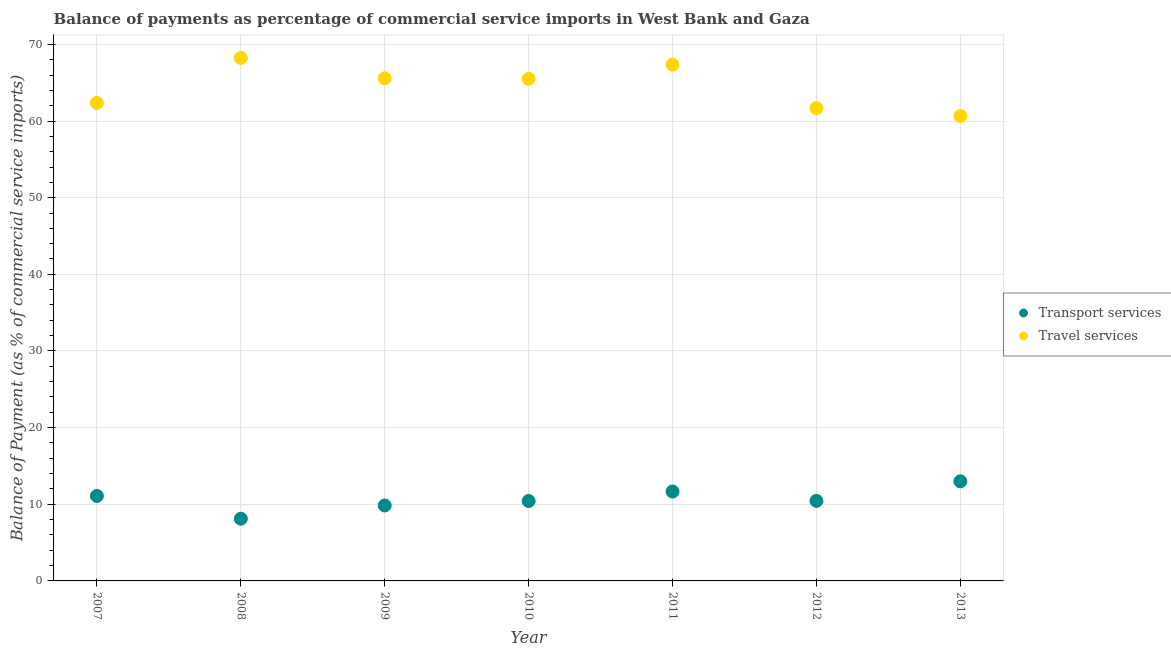How many different coloured dotlines are there?
Make the answer very short. 2. Is the number of dotlines equal to the number of legend labels?
Give a very brief answer. Yes. What is the balance of payments of transport services in 2010?
Your answer should be compact. 10.43. Across all years, what is the maximum balance of payments of transport services?
Offer a very short reply. 12.99. Across all years, what is the minimum balance of payments of travel services?
Make the answer very short. 60.66. In which year was the balance of payments of travel services maximum?
Offer a terse response. 2008. In which year was the balance of payments of transport services minimum?
Your answer should be compact. 2008. What is the total balance of payments of transport services in the graph?
Your answer should be very brief. 74.57. What is the difference between the balance of payments of transport services in 2008 and that in 2013?
Keep it short and to the point. -4.88. What is the difference between the balance of payments of travel services in 2010 and the balance of payments of transport services in 2012?
Offer a very short reply. 55.06. What is the average balance of payments of transport services per year?
Your response must be concise. 10.65. In the year 2008, what is the difference between the balance of payments of travel services and balance of payments of transport services?
Provide a short and direct response. 60.12. What is the ratio of the balance of payments of transport services in 2007 to that in 2010?
Ensure brevity in your answer.  1.06. Is the balance of payments of transport services in 2007 less than that in 2012?
Provide a short and direct response. No. Is the difference between the balance of payments of transport services in 2007 and 2010 greater than the difference between the balance of payments of travel services in 2007 and 2010?
Keep it short and to the point. Yes. What is the difference between the highest and the second highest balance of payments of transport services?
Provide a short and direct response. 1.33. What is the difference between the highest and the lowest balance of payments of transport services?
Make the answer very short. 4.88. Is the sum of the balance of payments of transport services in 2008 and 2013 greater than the maximum balance of payments of travel services across all years?
Give a very brief answer. No. Does the balance of payments of travel services monotonically increase over the years?
Provide a succinct answer. No. Is the balance of payments of travel services strictly greater than the balance of payments of transport services over the years?
Your answer should be very brief. Yes. How many dotlines are there?
Your answer should be very brief. 2. Does the graph contain grids?
Offer a terse response. Yes. Where does the legend appear in the graph?
Your answer should be compact. Center right. How many legend labels are there?
Offer a very short reply. 2. What is the title of the graph?
Your response must be concise. Balance of payments as percentage of commercial service imports in West Bank and Gaza. What is the label or title of the X-axis?
Offer a very short reply. Year. What is the label or title of the Y-axis?
Keep it short and to the point. Balance of Payment (as % of commercial service imports). What is the Balance of Payment (as % of commercial service imports) in Transport services in 2007?
Make the answer very short. 11.09. What is the Balance of Payment (as % of commercial service imports) of Travel services in 2007?
Your response must be concise. 62.36. What is the Balance of Payment (as % of commercial service imports) in Transport services in 2008?
Make the answer very short. 8.12. What is the Balance of Payment (as % of commercial service imports) of Travel services in 2008?
Ensure brevity in your answer.  68.23. What is the Balance of Payment (as % of commercial service imports) of Transport services in 2009?
Keep it short and to the point. 9.84. What is the Balance of Payment (as % of commercial service imports) of Travel services in 2009?
Keep it short and to the point. 65.57. What is the Balance of Payment (as % of commercial service imports) in Transport services in 2010?
Offer a terse response. 10.43. What is the Balance of Payment (as % of commercial service imports) in Travel services in 2010?
Your answer should be very brief. 65.5. What is the Balance of Payment (as % of commercial service imports) in Transport services in 2011?
Offer a very short reply. 11.66. What is the Balance of Payment (as % of commercial service imports) in Travel services in 2011?
Offer a very short reply. 67.34. What is the Balance of Payment (as % of commercial service imports) of Transport services in 2012?
Ensure brevity in your answer.  10.44. What is the Balance of Payment (as % of commercial service imports) of Travel services in 2012?
Offer a very short reply. 61.69. What is the Balance of Payment (as % of commercial service imports) in Transport services in 2013?
Offer a very short reply. 12.99. What is the Balance of Payment (as % of commercial service imports) in Travel services in 2013?
Offer a terse response. 60.66. Across all years, what is the maximum Balance of Payment (as % of commercial service imports) of Transport services?
Ensure brevity in your answer.  12.99. Across all years, what is the maximum Balance of Payment (as % of commercial service imports) in Travel services?
Provide a short and direct response. 68.23. Across all years, what is the minimum Balance of Payment (as % of commercial service imports) of Transport services?
Offer a terse response. 8.12. Across all years, what is the minimum Balance of Payment (as % of commercial service imports) in Travel services?
Your response must be concise. 60.66. What is the total Balance of Payment (as % of commercial service imports) of Transport services in the graph?
Provide a short and direct response. 74.57. What is the total Balance of Payment (as % of commercial service imports) of Travel services in the graph?
Provide a succinct answer. 451.36. What is the difference between the Balance of Payment (as % of commercial service imports) in Transport services in 2007 and that in 2008?
Offer a terse response. 2.97. What is the difference between the Balance of Payment (as % of commercial service imports) of Travel services in 2007 and that in 2008?
Ensure brevity in your answer.  -5.88. What is the difference between the Balance of Payment (as % of commercial service imports) of Transport services in 2007 and that in 2009?
Offer a very short reply. 1.24. What is the difference between the Balance of Payment (as % of commercial service imports) of Travel services in 2007 and that in 2009?
Your answer should be very brief. -3.22. What is the difference between the Balance of Payment (as % of commercial service imports) of Transport services in 2007 and that in 2010?
Keep it short and to the point. 0.66. What is the difference between the Balance of Payment (as % of commercial service imports) in Travel services in 2007 and that in 2010?
Your answer should be very brief. -3.15. What is the difference between the Balance of Payment (as % of commercial service imports) in Transport services in 2007 and that in 2011?
Make the answer very short. -0.58. What is the difference between the Balance of Payment (as % of commercial service imports) of Travel services in 2007 and that in 2011?
Offer a very short reply. -4.99. What is the difference between the Balance of Payment (as % of commercial service imports) of Transport services in 2007 and that in 2012?
Offer a terse response. 0.64. What is the difference between the Balance of Payment (as % of commercial service imports) of Travel services in 2007 and that in 2012?
Provide a succinct answer. 0.67. What is the difference between the Balance of Payment (as % of commercial service imports) of Transport services in 2007 and that in 2013?
Provide a succinct answer. -1.91. What is the difference between the Balance of Payment (as % of commercial service imports) in Travel services in 2007 and that in 2013?
Your response must be concise. 1.7. What is the difference between the Balance of Payment (as % of commercial service imports) in Transport services in 2008 and that in 2009?
Your answer should be very brief. -1.72. What is the difference between the Balance of Payment (as % of commercial service imports) in Travel services in 2008 and that in 2009?
Offer a very short reply. 2.66. What is the difference between the Balance of Payment (as % of commercial service imports) of Transport services in 2008 and that in 2010?
Make the answer very short. -2.31. What is the difference between the Balance of Payment (as % of commercial service imports) of Travel services in 2008 and that in 2010?
Give a very brief answer. 2.73. What is the difference between the Balance of Payment (as % of commercial service imports) in Transport services in 2008 and that in 2011?
Offer a terse response. -3.55. What is the difference between the Balance of Payment (as % of commercial service imports) of Travel services in 2008 and that in 2011?
Your answer should be very brief. 0.89. What is the difference between the Balance of Payment (as % of commercial service imports) of Transport services in 2008 and that in 2012?
Your answer should be very brief. -2.32. What is the difference between the Balance of Payment (as % of commercial service imports) of Travel services in 2008 and that in 2012?
Your answer should be very brief. 6.54. What is the difference between the Balance of Payment (as % of commercial service imports) of Transport services in 2008 and that in 2013?
Your answer should be very brief. -4.88. What is the difference between the Balance of Payment (as % of commercial service imports) of Travel services in 2008 and that in 2013?
Offer a terse response. 7.57. What is the difference between the Balance of Payment (as % of commercial service imports) of Transport services in 2009 and that in 2010?
Offer a very short reply. -0.58. What is the difference between the Balance of Payment (as % of commercial service imports) of Travel services in 2009 and that in 2010?
Keep it short and to the point. 0.07. What is the difference between the Balance of Payment (as % of commercial service imports) in Transport services in 2009 and that in 2011?
Provide a succinct answer. -1.82. What is the difference between the Balance of Payment (as % of commercial service imports) in Travel services in 2009 and that in 2011?
Offer a very short reply. -1.77. What is the difference between the Balance of Payment (as % of commercial service imports) in Transport services in 2009 and that in 2012?
Offer a terse response. -0.6. What is the difference between the Balance of Payment (as % of commercial service imports) of Travel services in 2009 and that in 2012?
Give a very brief answer. 3.89. What is the difference between the Balance of Payment (as % of commercial service imports) of Transport services in 2009 and that in 2013?
Provide a short and direct response. -3.15. What is the difference between the Balance of Payment (as % of commercial service imports) in Travel services in 2009 and that in 2013?
Make the answer very short. 4.91. What is the difference between the Balance of Payment (as % of commercial service imports) of Transport services in 2010 and that in 2011?
Offer a terse response. -1.24. What is the difference between the Balance of Payment (as % of commercial service imports) of Travel services in 2010 and that in 2011?
Provide a succinct answer. -1.84. What is the difference between the Balance of Payment (as % of commercial service imports) of Transport services in 2010 and that in 2012?
Provide a succinct answer. -0.02. What is the difference between the Balance of Payment (as % of commercial service imports) of Travel services in 2010 and that in 2012?
Give a very brief answer. 3.81. What is the difference between the Balance of Payment (as % of commercial service imports) of Transport services in 2010 and that in 2013?
Your answer should be very brief. -2.57. What is the difference between the Balance of Payment (as % of commercial service imports) in Travel services in 2010 and that in 2013?
Offer a terse response. 4.84. What is the difference between the Balance of Payment (as % of commercial service imports) of Transport services in 2011 and that in 2012?
Ensure brevity in your answer.  1.22. What is the difference between the Balance of Payment (as % of commercial service imports) of Travel services in 2011 and that in 2012?
Provide a succinct answer. 5.65. What is the difference between the Balance of Payment (as % of commercial service imports) in Transport services in 2011 and that in 2013?
Your answer should be compact. -1.33. What is the difference between the Balance of Payment (as % of commercial service imports) in Travel services in 2011 and that in 2013?
Make the answer very short. 6.68. What is the difference between the Balance of Payment (as % of commercial service imports) of Transport services in 2012 and that in 2013?
Make the answer very short. -2.55. What is the difference between the Balance of Payment (as % of commercial service imports) of Travel services in 2012 and that in 2013?
Keep it short and to the point. 1.03. What is the difference between the Balance of Payment (as % of commercial service imports) in Transport services in 2007 and the Balance of Payment (as % of commercial service imports) in Travel services in 2008?
Offer a terse response. -57.15. What is the difference between the Balance of Payment (as % of commercial service imports) of Transport services in 2007 and the Balance of Payment (as % of commercial service imports) of Travel services in 2009?
Your answer should be very brief. -54.49. What is the difference between the Balance of Payment (as % of commercial service imports) of Transport services in 2007 and the Balance of Payment (as % of commercial service imports) of Travel services in 2010?
Your answer should be very brief. -54.42. What is the difference between the Balance of Payment (as % of commercial service imports) of Transport services in 2007 and the Balance of Payment (as % of commercial service imports) of Travel services in 2011?
Give a very brief answer. -56.26. What is the difference between the Balance of Payment (as % of commercial service imports) in Transport services in 2007 and the Balance of Payment (as % of commercial service imports) in Travel services in 2012?
Your answer should be compact. -50.6. What is the difference between the Balance of Payment (as % of commercial service imports) of Transport services in 2007 and the Balance of Payment (as % of commercial service imports) of Travel services in 2013?
Provide a short and direct response. -49.58. What is the difference between the Balance of Payment (as % of commercial service imports) in Transport services in 2008 and the Balance of Payment (as % of commercial service imports) in Travel services in 2009?
Make the answer very short. -57.46. What is the difference between the Balance of Payment (as % of commercial service imports) in Transport services in 2008 and the Balance of Payment (as % of commercial service imports) in Travel services in 2010?
Provide a short and direct response. -57.38. What is the difference between the Balance of Payment (as % of commercial service imports) of Transport services in 2008 and the Balance of Payment (as % of commercial service imports) of Travel services in 2011?
Your answer should be very brief. -59.23. What is the difference between the Balance of Payment (as % of commercial service imports) in Transport services in 2008 and the Balance of Payment (as % of commercial service imports) in Travel services in 2012?
Make the answer very short. -53.57. What is the difference between the Balance of Payment (as % of commercial service imports) in Transport services in 2008 and the Balance of Payment (as % of commercial service imports) in Travel services in 2013?
Your answer should be compact. -52.54. What is the difference between the Balance of Payment (as % of commercial service imports) in Transport services in 2009 and the Balance of Payment (as % of commercial service imports) in Travel services in 2010?
Offer a very short reply. -55.66. What is the difference between the Balance of Payment (as % of commercial service imports) in Transport services in 2009 and the Balance of Payment (as % of commercial service imports) in Travel services in 2011?
Ensure brevity in your answer.  -57.5. What is the difference between the Balance of Payment (as % of commercial service imports) of Transport services in 2009 and the Balance of Payment (as % of commercial service imports) of Travel services in 2012?
Make the answer very short. -51.85. What is the difference between the Balance of Payment (as % of commercial service imports) of Transport services in 2009 and the Balance of Payment (as % of commercial service imports) of Travel services in 2013?
Offer a terse response. -50.82. What is the difference between the Balance of Payment (as % of commercial service imports) in Transport services in 2010 and the Balance of Payment (as % of commercial service imports) in Travel services in 2011?
Ensure brevity in your answer.  -56.92. What is the difference between the Balance of Payment (as % of commercial service imports) in Transport services in 2010 and the Balance of Payment (as % of commercial service imports) in Travel services in 2012?
Keep it short and to the point. -51.26. What is the difference between the Balance of Payment (as % of commercial service imports) of Transport services in 2010 and the Balance of Payment (as % of commercial service imports) of Travel services in 2013?
Make the answer very short. -50.24. What is the difference between the Balance of Payment (as % of commercial service imports) of Transport services in 2011 and the Balance of Payment (as % of commercial service imports) of Travel services in 2012?
Your response must be concise. -50.03. What is the difference between the Balance of Payment (as % of commercial service imports) of Transport services in 2011 and the Balance of Payment (as % of commercial service imports) of Travel services in 2013?
Your response must be concise. -49. What is the difference between the Balance of Payment (as % of commercial service imports) of Transport services in 2012 and the Balance of Payment (as % of commercial service imports) of Travel services in 2013?
Provide a short and direct response. -50.22. What is the average Balance of Payment (as % of commercial service imports) in Transport services per year?
Offer a very short reply. 10.65. What is the average Balance of Payment (as % of commercial service imports) in Travel services per year?
Give a very brief answer. 64.48. In the year 2007, what is the difference between the Balance of Payment (as % of commercial service imports) in Transport services and Balance of Payment (as % of commercial service imports) in Travel services?
Offer a very short reply. -51.27. In the year 2008, what is the difference between the Balance of Payment (as % of commercial service imports) of Transport services and Balance of Payment (as % of commercial service imports) of Travel services?
Keep it short and to the point. -60.12. In the year 2009, what is the difference between the Balance of Payment (as % of commercial service imports) in Transport services and Balance of Payment (as % of commercial service imports) in Travel services?
Ensure brevity in your answer.  -55.73. In the year 2010, what is the difference between the Balance of Payment (as % of commercial service imports) of Transport services and Balance of Payment (as % of commercial service imports) of Travel services?
Keep it short and to the point. -55.08. In the year 2011, what is the difference between the Balance of Payment (as % of commercial service imports) in Transport services and Balance of Payment (as % of commercial service imports) in Travel services?
Offer a very short reply. -55.68. In the year 2012, what is the difference between the Balance of Payment (as % of commercial service imports) in Transport services and Balance of Payment (as % of commercial service imports) in Travel services?
Make the answer very short. -51.25. In the year 2013, what is the difference between the Balance of Payment (as % of commercial service imports) of Transport services and Balance of Payment (as % of commercial service imports) of Travel services?
Make the answer very short. -47.67. What is the ratio of the Balance of Payment (as % of commercial service imports) of Transport services in 2007 to that in 2008?
Your answer should be very brief. 1.37. What is the ratio of the Balance of Payment (as % of commercial service imports) in Travel services in 2007 to that in 2008?
Keep it short and to the point. 0.91. What is the ratio of the Balance of Payment (as % of commercial service imports) of Transport services in 2007 to that in 2009?
Keep it short and to the point. 1.13. What is the ratio of the Balance of Payment (as % of commercial service imports) in Travel services in 2007 to that in 2009?
Your response must be concise. 0.95. What is the ratio of the Balance of Payment (as % of commercial service imports) in Transport services in 2007 to that in 2010?
Offer a terse response. 1.06. What is the ratio of the Balance of Payment (as % of commercial service imports) in Transport services in 2007 to that in 2011?
Your response must be concise. 0.95. What is the ratio of the Balance of Payment (as % of commercial service imports) of Travel services in 2007 to that in 2011?
Offer a very short reply. 0.93. What is the ratio of the Balance of Payment (as % of commercial service imports) of Transport services in 2007 to that in 2012?
Make the answer very short. 1.06. What is the ratio of the Balance of Payment (as % of commercial service imports) of Travel services in 2007 to that in 2012?
Keep it short and to the point. 1.01. What is the ratio of the Balance of Payment (as % of commercial service imports) in Transport services in 2007 to that in 2013?
Offer a very short reply. 0.85. What is the ratio of the Balance of Payment (as % of commercial service imports) in Travel services in 2007 to that in 2013?
Make the answer very short. 1.03. What is the ratio of the Balance of Payment (as % of commercial service imports) in Transport services in 2008 to that in 2009?
Your answer should be very brief. 0.82. What is the ratio of the Balance of Payment (as % of commercial service imports) in Travel services in 2008 to that in 2009?
Offer a terse response. 1.04. What is the ratio of the Balance of Payment (as % of commercial service imports) in Transport services in 2008 to that in 2010?
Make the answer very short. 0.78. What is the ratio of the Balance of Payment (as % of commercial service imports) of Travel services in 2008 to that in 2010?
Your response must be concise. 1.04. What is the ratio of the Balance of Payment (as % of commercial service imports) in Transport services in 2008 to that in 2011?
Keep it short and to the point. 0.7. What is the ratio of the Balance of Payment (as % of commercial service imports) of Travel services in 2008 to that in 2011?
Offer a very short reply. 1.01. What is the ratio of the Balance of Payment (as % of commercial service imports) in Transport services in 2008 to that in 2012?
Provide a succinct answer. 0.78. What is the ratio of the Balance of Payment (as % of commercial service imports) of Travel services in 2008 to that in 2012?
Keep it short and to the point. 1.11. What is the ratio of the Balance of Payment (as % of commercial service imports) in Transport services in 2008 to that in 2013?
Your answer should be compact. 0.62. What is the ratio of the Balance of Payment (as % of commercial service imports) of Travel services in 2008 to that in 2013?
Offer a terse response. 1.12. What is the ratio of the Balance of Payment (as % of commercial service imports) in Transport services in 2009 to that in 2010?
Your response must be concise. 0.94. What is the ratio of the Balance of Payment (as % of commercial service imports) in Transport services in 2009 to that in 2011?
Your answer should be compact. 0.84. What is the ratio of the Balance of Payment (as % of commercial service imports) in Travel services in 2009 to that in 2011?
Give a very brief answer. 0.97. What is the ratio of the Balance of Payment (as % of commercial service imports) in Transport services in 2009 to that in 2012?
Offer a very short reply. 0.94. What is the ratio of the Balance of Payment (as % of commercial service imports) of Travel services in 2009 to that in 2012?
Give a very brief answer. 1.06. What is the ratio of the Balance of Payment (as % of commercial service imports) in Transport services in 2009 to that in 2013?
Your answer should be very brief. 0.76. What is the ratio of the Balance of Payment (as % of commercial service imports) of Travel services in 2009 to that in 2013?
Your response must be concise. 1.08. What is the ratio of the Balance of Payment (as % of commercial service imports) in Transport services in 2010 to that in 2011?
Your answer should be very brief. 0.89. What is the ratio of the Balance of Payment (as % of commercial service imports) of Travel services in 2010 to that in 2011?
Keep it short and to the point. 0.97. What is the ratio of the Balance of Payment (as % of commercial service imports) in Travel services in 2010 to that in 2012?
Make the answer very short. 1.06. What is the ratio of the Balance of Payment (as % of commercial service imports) of Transport services in 2010 to that in 2013?
Keep it short and to the point. 0.8. What is the ratio of the Balance of Payment (as % of commercial service imports) in Travel services in 2010 to that in 2013?
Your response must be concise. 1.08. What is the ratio of the Balance of Payment (as % of commercial service imports) in Transport services in 2011 to that in 2012?
Your answer should be compact. 1.12. What is the ratio of the Balance of Payment (as % of commercial service imports) of Travel services in 2011 to that in 2012?
Keep it short and to the point. 1.09. What is the ratio of the Balance of Payment (as % of commercial service imports) of Transport services in 2011 to that in 2013?
Keep it short and to the point. 0.9. What is the ratio of the Balance of Payment (as % of commercial service imports) of Travel services in 2011 to that in 2013?
Make the answer very short. 1.11. What is the ratio of the Balance of Payment (as % of commercial service imports) in Transport services in 2012 to that in 2013?
Offer a very short reply. 0.8. What is the difference between the highest and the second highest Balance of Payment (as % of commercial service imports) in Transport services?
Provide a succinct answer. 1.33. What is the difference between the highest and the second highest Balance of Payment (as % of commercial service imports) of Travel services?
Your answer should be compact. 0.89. What is the difference between the highest and the lowest Balance of Payment (as % of commercial service imports) of Transport services?
Your answer should be very brief. 4.88. What is the difference between the highest and the lowest Balance of Payment (as % of commercial service imports) in Travel services?
Keep it short and to the point. 7.57. 